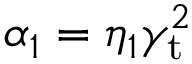<formula> <loc_0><loc_0><loc_500><loc_500>\alpha _ { 1 } = \eta _ { 1 } \gamma _ { t } ^ { 2 }</formula> 